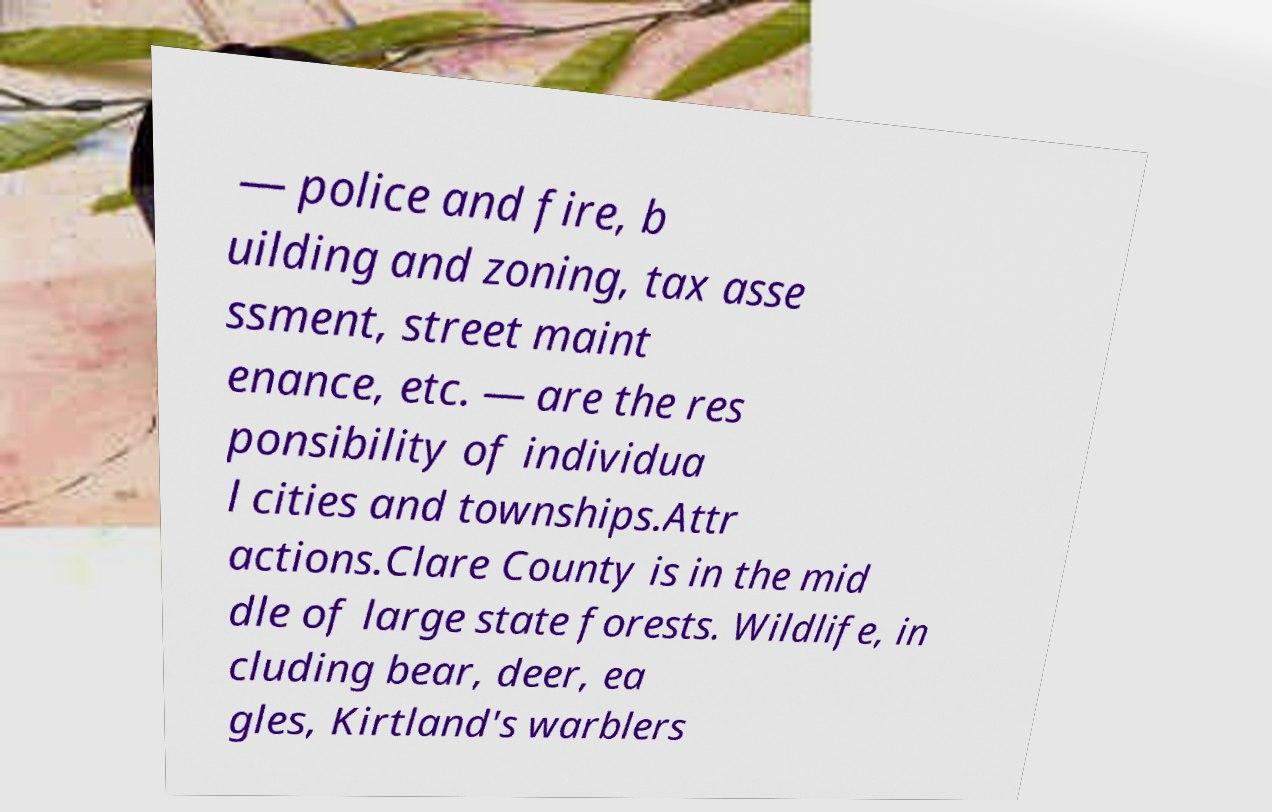Please identify and transcribe the text found in this image. — police and fire, b uilding and zoning, tax asse ssment, street maint enance, etc. — are the res ponsibility of individua l cities and townships.Attr actions.Clare County is in the mid dle of large state forests. Wildlife, in cluding bear, deer, ea gles, Kirtland's warblers 